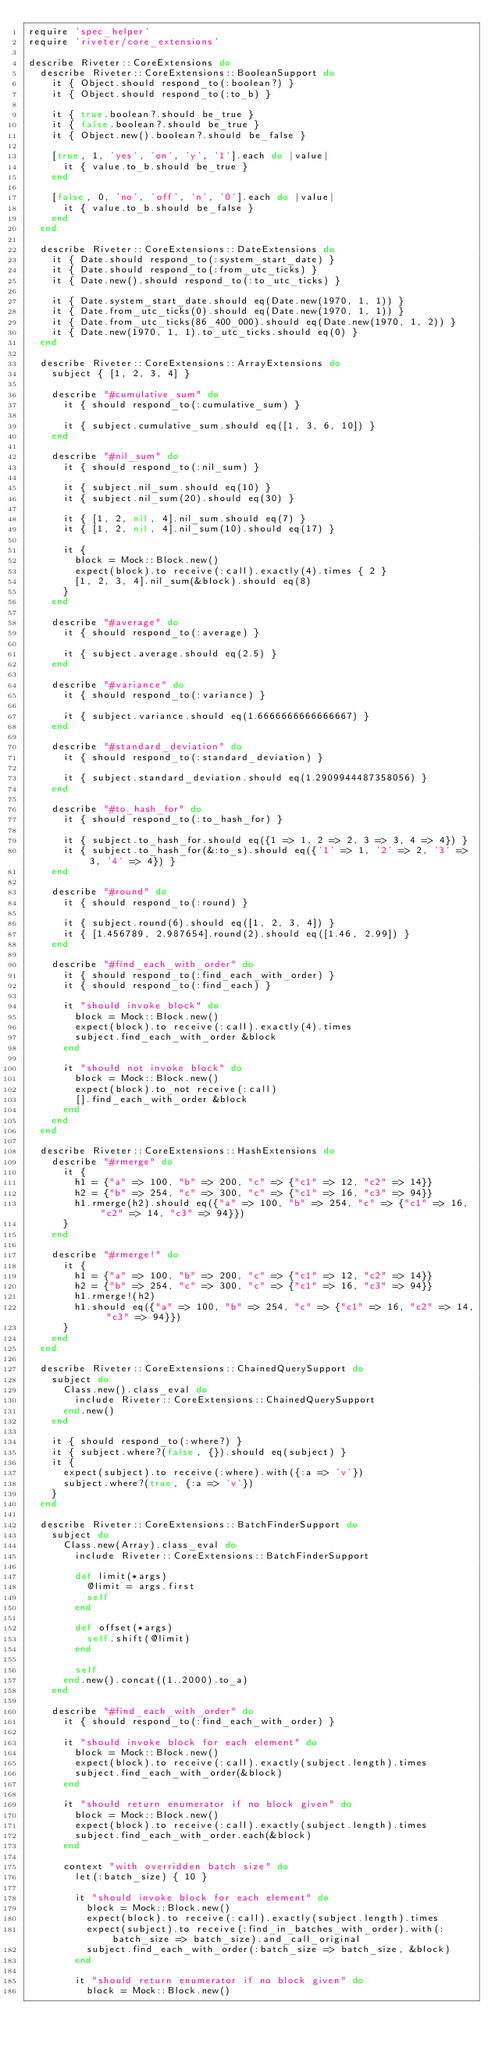<code> <loc_0><loc_0><loc_500><loc_500><_Ruby_>require 'spec_helper'
require 'riveter/core_extensions'

describe Riveter::CoreExtensions do
  describe Riveter::CoreExtensions::BooleanSupport do
    it { Object.should respond_to(:boolean?) }
    it { Object.should respond_to(:to_b) }

    it { true.boolean?.should be_true }
    it { false.boolean?.should be_true }
    it { Object.new().boolean?.should be_false }

    [true, 1, 'yes', 'on', 'y', '1'].each do |value|
      it { value.to_b.should be_true }
    end

    [false, 0, 'no', 'off', 'n', '0'].each do |value|
      it { value.to_b.should be_false }
    end
  end

  describe Riveter::CoreExtensions::DateExtensions do
    it { Date.should respond_to(:system_start_date) }
    it { Date.should respond_to(:from_utc_ticks) }
    it { Date.new().should respond_to(:to_utc_ticks) }

    it { Date.system_start_date.should eq(Date.new(1970, 1, 1)) }
    it { Date.from_utc_ticks(0).should eq(Date.new(1970, 1, 1)) }
    it { Date.from_utc_ticks(86_400_000).should eq(Date.new(1970, 1, 2)) }
    it { Date.new(1970, 1, 1).to_utc_ticks.should eq(0) }
  end

  describe Riveter::CoreExtensions::ArrayExtensions do
    subject { [1, 2, 3, 4] }

    describe "#cumulative_sum" do
      it { should respond_to(:cumulative_sum) }

      it { subject.cumulative_sum.should eq([1, 3, 6, 10]) }
    end

    describe "#nil_sum" do
      it { should respond_to(:nil_sum) }

      it { subject.nil_sum.should eq(10) }
      it { subject.nil_sum(20).should eq(30) }

      it { [1, 2, nil, 4].nil_sum.should eq(7) }
      it { [1, 2, nil, 4].nil_sum(10).should eq(17) }

      it {
        block = Mock::Block.new()
        expect(block).to receive(:call).exactly(4).times { 2 }
        [1, 2, 3, 4].nil_sum(&block).should eq(8)
      }
    end

    describe "#average" do
      it { should respond_to(:average) }

      it { subject.average.should eq(2.5) }
    end

    describe "#variance" do
      it { should respond_to(:variance) }

      it { subject.variance.should eq(1.6666666666666667) }
    end

    describe "#standard_deviation" do
      it { should respond_to(:standard_deviation) }

      it { subject.standard_deviation.should eq(1.2909944487358056) }
    end

    describe "#to_hash_for" do
      it { should respond_to(:to_hash_for) }

      it { subject.to_hash_for.should eq({1 => 1, 2 => 2, 3 => 3, 4 => 4}) }
      it { subject.to_hash_for(&:to_s).should eq({'1' => 1, '2' => 2, '3' => 3, '4' => 4}) }
    end

    describe "#round" do
      it { should respond_to(:round) }

      it { subject.round(6).should eq([1, 2, 3, 4]) }
      it { [1.456789, 2.987654].round(2).should eq([1.46, 2.99]) }
    end

    describe "#find_each_with_order" do
      it { should respond_to(:find_each_with_order) }
      it { should respond_to(:find_each) }

      it "should invoke block" do
        block = Mock::Block.new()
        expect(block).to receive(:call).exactly(4).times
        subject.find_each_with_order &block
      end

      it "should not invoke block" do
        block = Mock::Block.new()
        expect(block).to_not receive(:call)
        [].find_each_with_order &block
      end
    end
  end

  describe Riveter::CoreExtensions::HashExtensions do
    describe "#rmerge" do
      it {
        h1 = {"a" => 100, "b" => 200, "c" => {"c1" => 12, "c2" => 14}}
        h2 = {"b" => 254, "c" => 300, "c" => {"c1" => 16, "c3" => 94}}
        h1.rmerge(h2).should eq({"a" => 100, "b" => 254, "c" => {"c1" => 16, "c2" => 14, "c3" => 94}})
      }
    end

    describe "#rmerge!" do
      it {
        h1 = {"a" => 100, "b" => 200, "c" => {"c1" => 12, "c2" => 14}}
        h2 = {"b" => 254, "c" => 300, "c" => {"c1" => 16, "c3" => 94}}
        h1.rmerge!(h2)
        h1.should eq({"a" => 100, "b" => 254, "c" => {"c1" => 16, "c2" => 14, "c3" => 94}})
      }
    end
  end

  describe Riveter::CoreExtensions::ChainedQuerySupport do
    subject do
      Class.new().class_eval do
        include Riveter::CoreExtensions::ChainedQuerySupport
      end.new()
    end

    it { should respond_to(:where?) }
    it { subject.where?(false, {}).should eq(subject) }
    it {
      expect(subject).to receive(:where).with({:a => 'v'})
      subject.where?(true, {:a => 'v'})
    }
  end

  describe Riveter::CoreExtensions::BatchFinderSupport do
    subject do
      Class.new(Array).class_eval do
        include Riveter::CoreExtensions::BatchFinderSupport

        def limit(*args)
          @limit = args.first
          self
        end

        def offset(*args)
          self.shift(@limit)
        end

        self
      end.new().concat((1..2000).to_a)
    end

    describe "#find_each_with_order" do
      it { should respond_to(:find_each_with_order) }

      it "should invoke block for each element" do
        block = Mock::Block.new()
        expect(block).to receive(:call).exactly(subject.length).times
        subject.find_each_with_order(&block)
      end

      it "should return enumerator if no block given" do
        block = Mock::Block.new()
        expect(block).to receive(:call).exactly(subject.length).times
        subject.find_each_with_order.each(&block)
      end

      context "with overridden batch size" do
        let(:batch_size) { 10 }

        it "should invoke block for each element" do
          block = Mock::Block.new()
          expect(block).to receive(:call).exactly(subject.length).times
          expect(subject).to receive(:find_in_batches_with_order).with(:batch_size => batch_size).and_call_original
          subject.find_each_with_order(:batch_size => batch_size, &block)
        end

        it "should return enumerator if no block given" do
          block = Mock::Block.new()</code> 